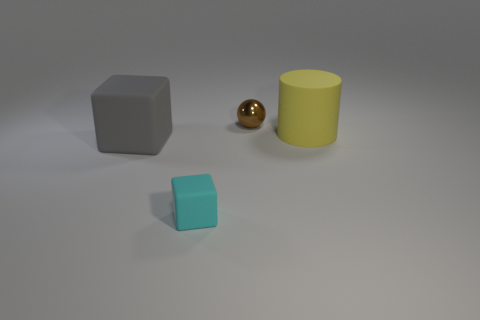Add 3 cyan things. How many objects exist? 7 Subtract all balls. How many objects are left? 3 Subtract all small purple cylinders. Subtract all gray matte things. How many objects are left? 3 Add 1 small metal things. How many small metal things are left? 2 Add 1 big brown matte blocks. How many big brown matte blocks exist? 1 Subtract 0 red cylinders. How many objects are left? 4 